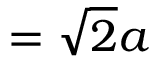<formula> <loc_0><loc_0><loc_500><loc_500>= { \sqrt { 2 } } a</formula> 